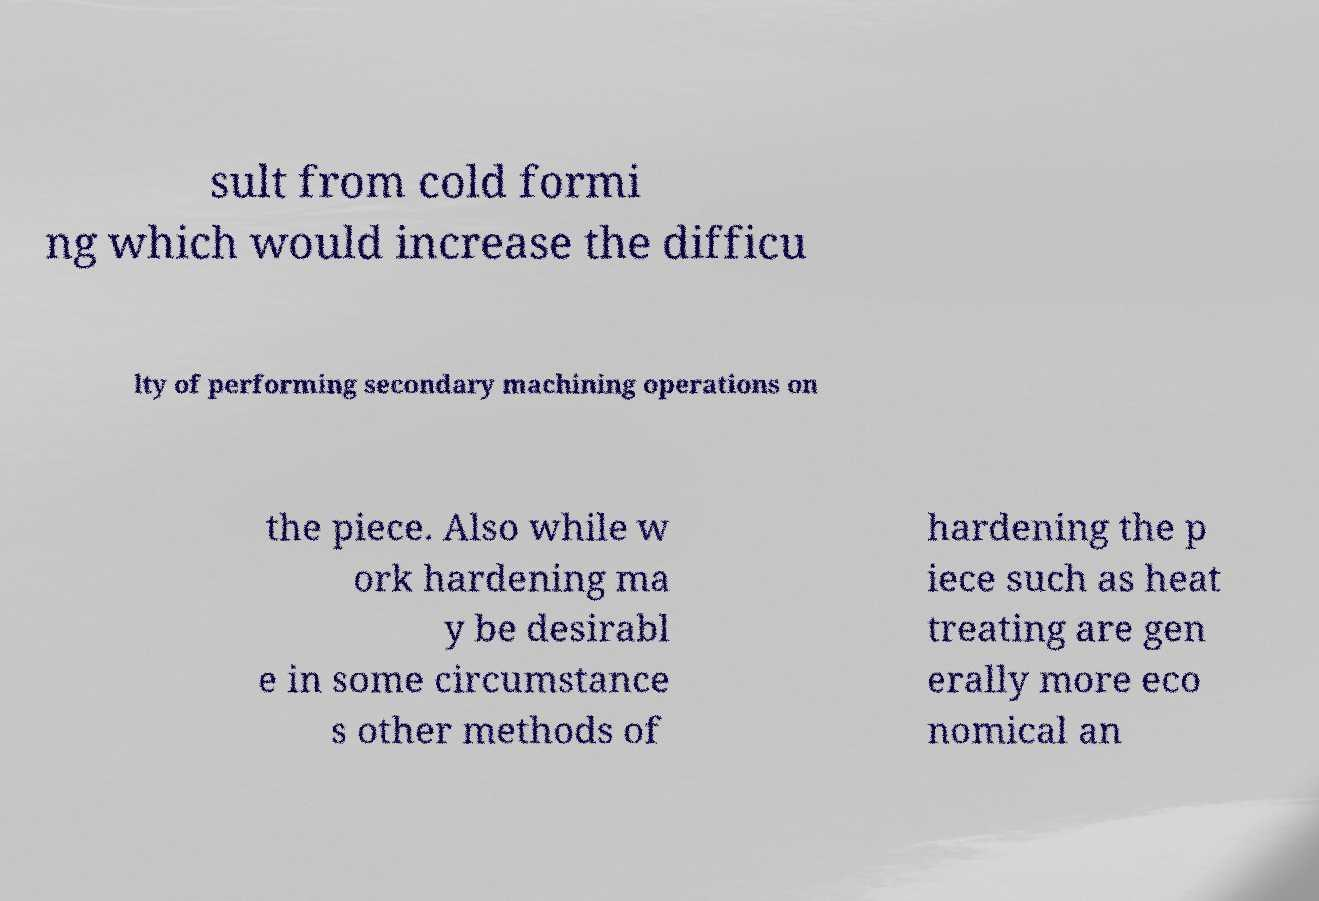Could you extract and type out the text from this image? sult from cold formi ng which would increase the difficu lty of performing secondary machining operations on the piece. Also while w ork hardening ma y be desirabl e in some circumstance s other methods of hardening the p iece such as heat treating are gen erally more eco nomical an 